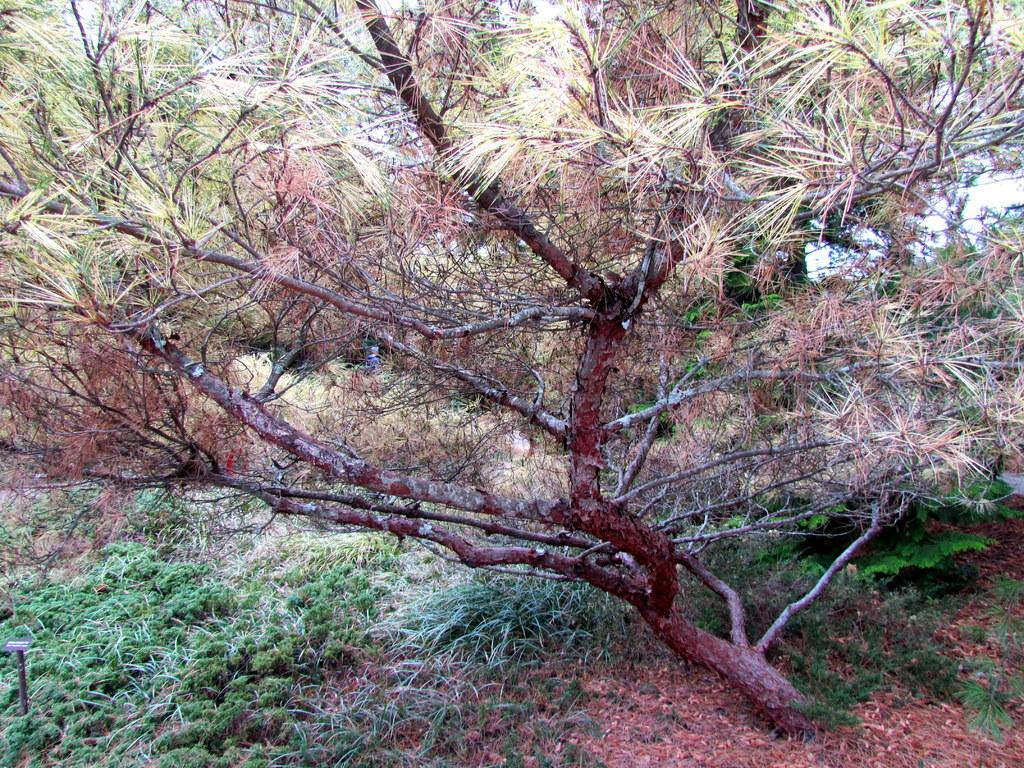What type of living organisms can be seen in the image? Plants can be seen in the image. What is located on the ground in the image? There is an object on the ground in the image. What can be seen in the background of the image? Trees and the sky are visible in the background of the image. What type of coil is being used to burn the plants in the image? There is no coil or burning of plants present in the image; it features plants and an object on the ground. What is the desire of the plants in the image? Plants do not have desires, as they are living organisms and not sentient beings. 